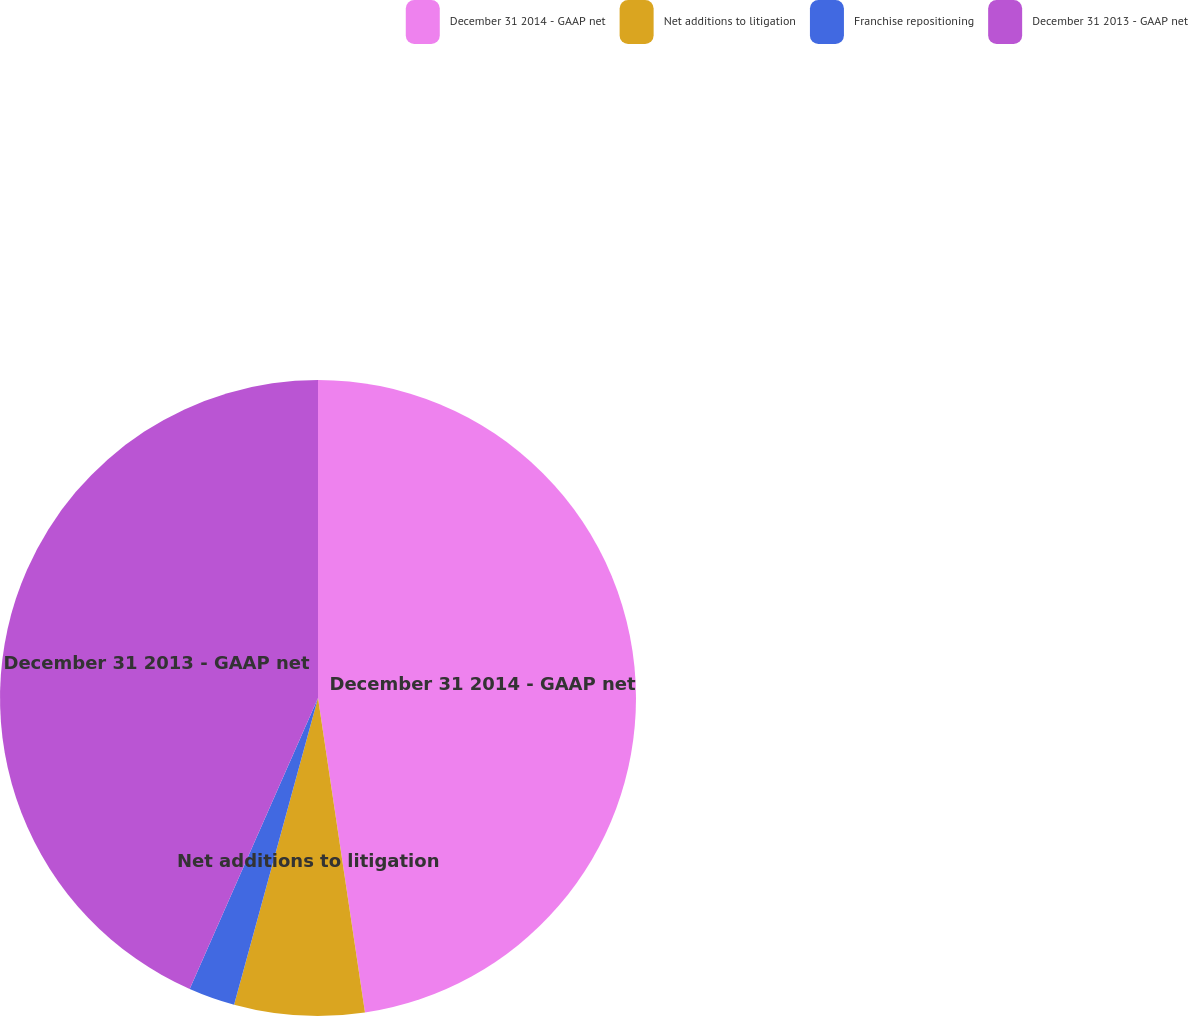Convert chart to OTSL. <chart><loc_0><loc_0><loc_500><loc_500><pie_chart><fcel>December 31 2014 - GAAP net<fcel>Net additions to litigation<fcel>Franchise repositioning<fcel>December 31 2013 - GAAP net<nl><fcel>47.64%<fcel>6.61%<fcel>2.36%<fcel>43.39%<nl></chart> 